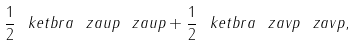Convert formula to latex. <formula><loc_0><loc_0><loc_500><loc_500>\frac { 1 } { 2 } \ k e t b r a { \ z a u p } { \ z a u p } + \frac { 1 } { 2 } \ k e t b r a { \ z a v p } { \ z a v p } ,</formula> 